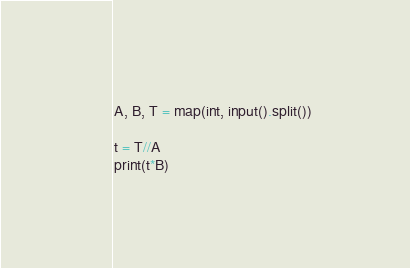Convert code to text. <code><loc_0><loc_0><loc_500><loc_500><_Python_>A, B, T = map(int, input().split())

t = T//A
print(t*B)</code> 